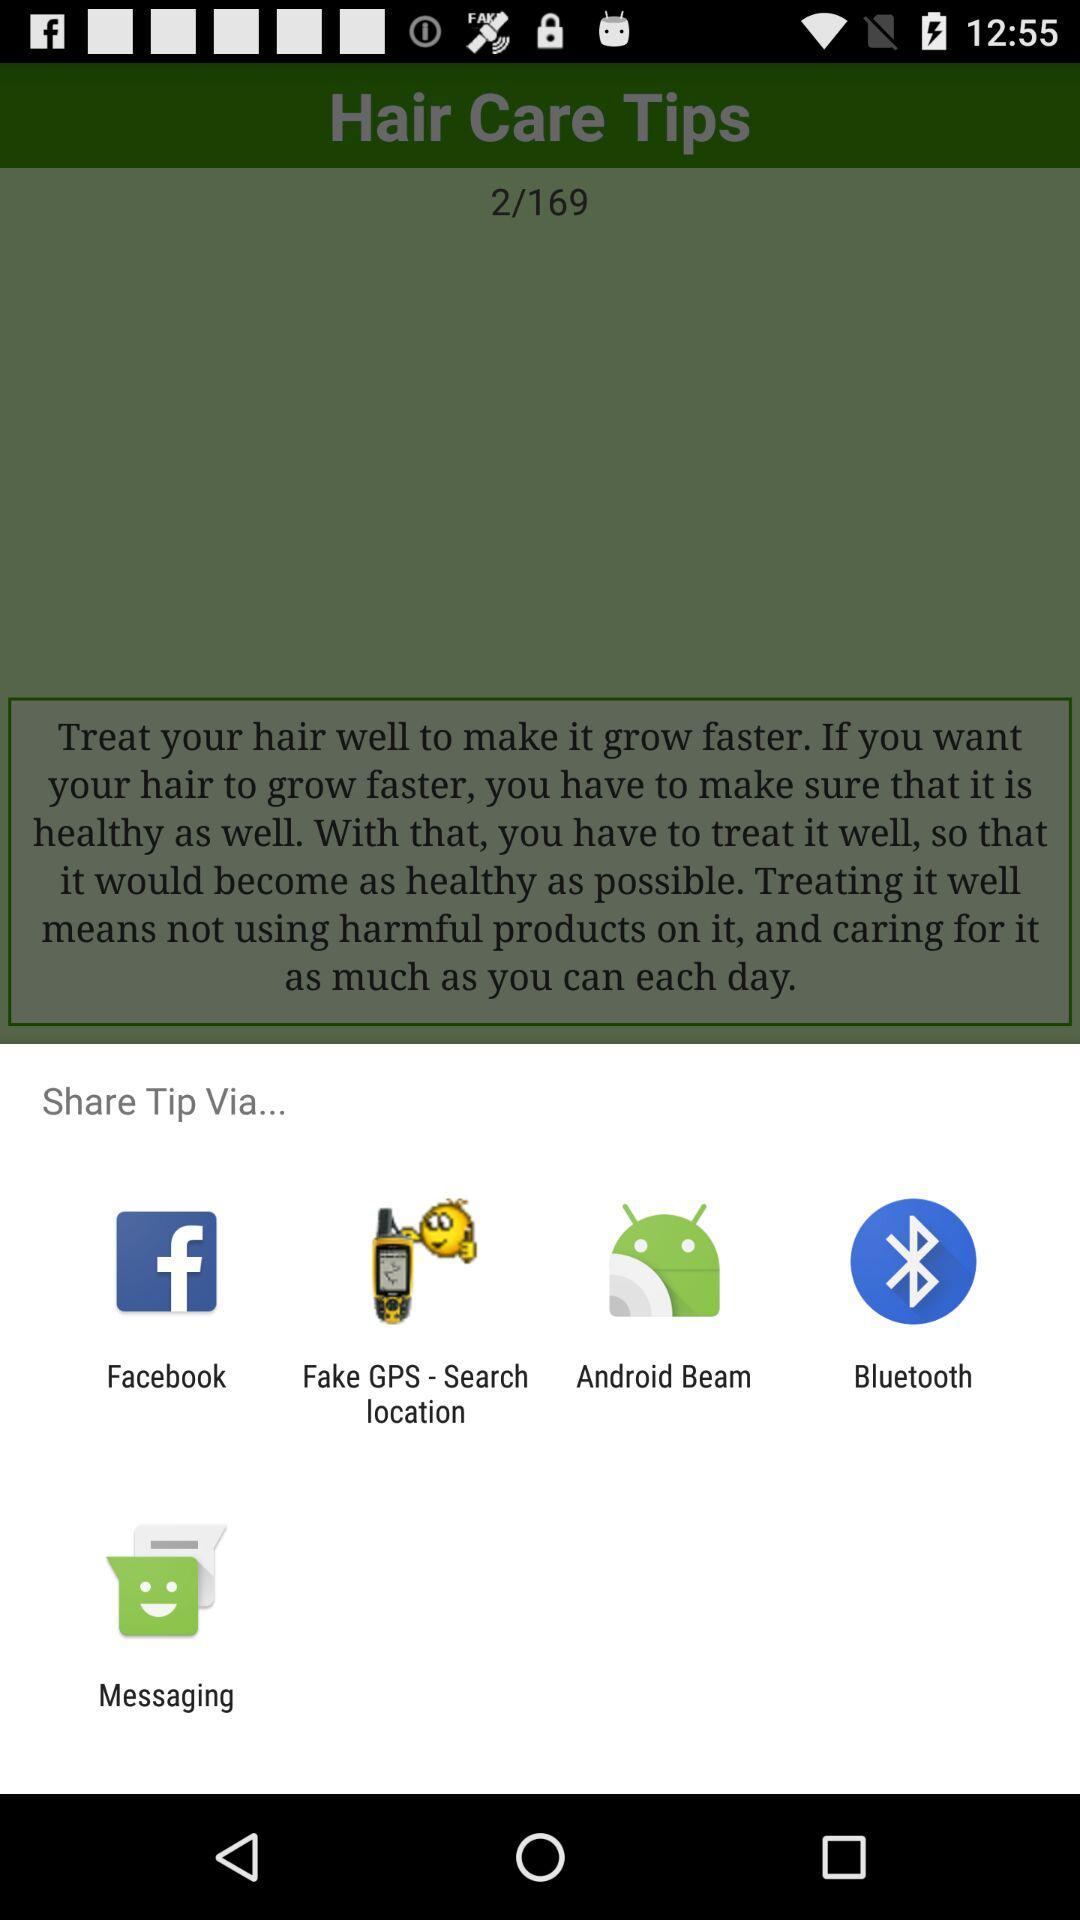From which app can we share it? You can share it with "Facebook", "Fake GPS - Search location", "Android Beam", "Bluetooth" and "Messaging". 